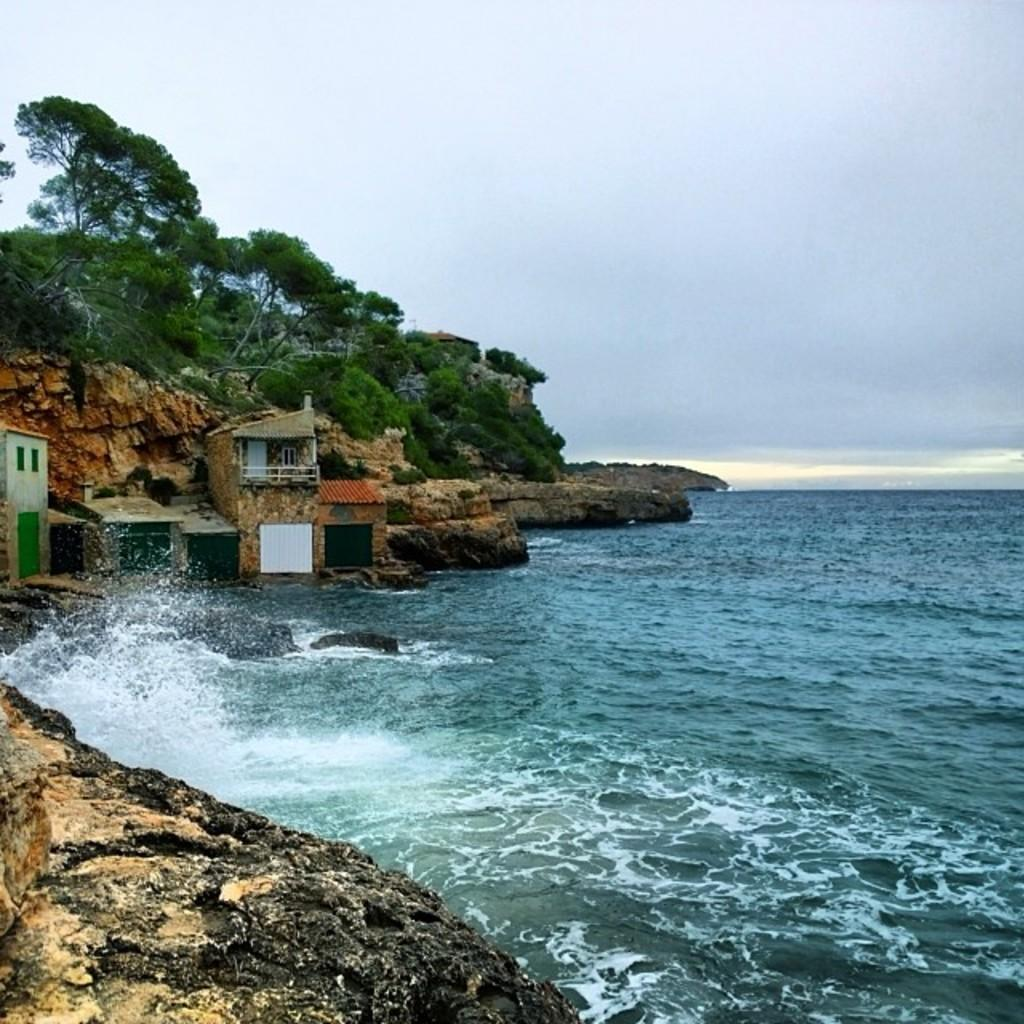What type of geographical feature is present in the image? There are rock hills in the image. What type of structures can be seen in the image? There are houses in the image. What natural element is visible in the image? There is water visible in the image. What type of vegetation is present in the image? There are trees in the image. What can be seen in the background of the image? The sky is visible in the background of the image. What type of lace is draped over the rock hills in the image? There is no lace present in the image; it features rock hills, houses, water, trees, and the sky. How many slaves can be seen working in the image? There are no slaves present in the image; it features rock hills, houses, water, trees, and the sky. 